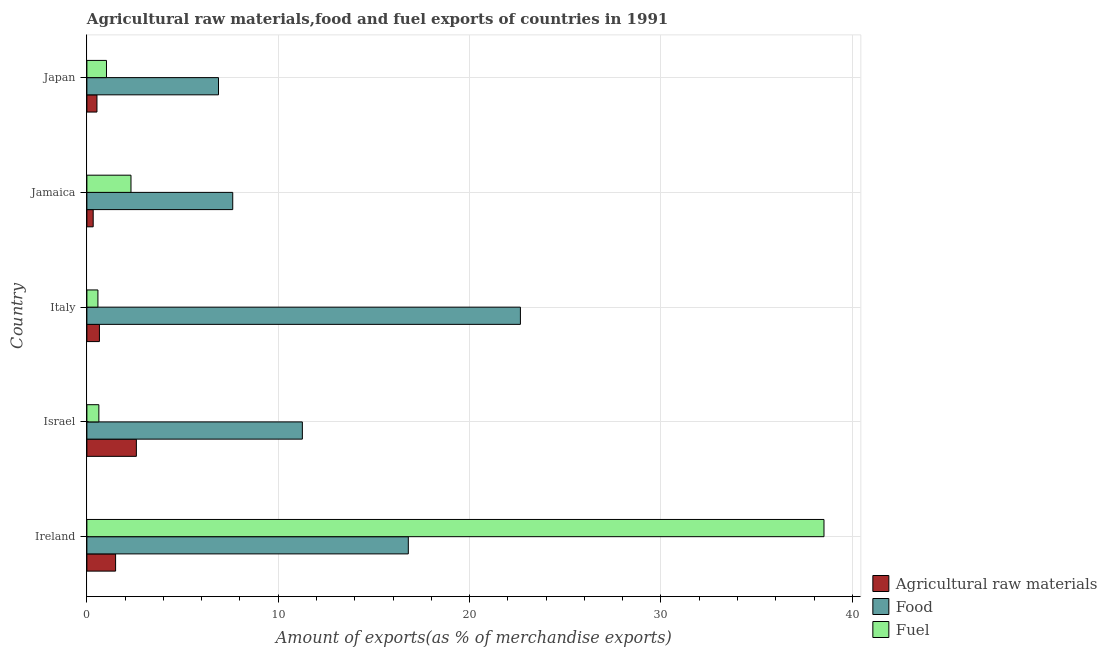Are the number of bars per tick equal to the number of legend labels?
Provide a short and direct response. Yes. How many bars are there on the 2nd tick from the bottom?
Provide a short and direct response. 3. What is the percentage of raw materials exports in Israel?
Give a very brief answer. 2.59. Across all countries, what is the maximum percentage of food exports?
Your response must be concise. 22.66. Across all countries, what is the minimum percentage of raw materials exports?
Keep it short and to the point. 0.33. In which country was the percentage of food exports minimum?
Offer a very short reply. Japan. What is the total percentage of raw materials exports in the graph?
Provide a succinct answer. 5.6. What is the difference between the percentage of raw materials exports in Japan and the percentage of food exports in Italy?
Keep it short and to the point. -22.13. What is the average percentage of food exports per country?
Give a very brief answer. 13.04. What is the difference between the percentage of raw materials exports and percentage of fuel exports in Japan?
Give a very brief answer. -0.5. What is the ratio of the percentage of food exports in Ireland to that in Italy?
Ensure brevity in your answer.  0.74. Is the percentage of fuel exports in Israel less than that in Italy?
Make the answer very short. No. What is the difference between the highest and the second highest percentage of food exports?
Give a very brief answer. 5.86. What is the difference between the highest and the lowest percentage of fuel exports?
Ensure brevity in your answer.  37.94. Is the sum of the percentage of fuel exports in Israel and Italy greater than the maximum percentage of raw materials exports across all countries?
Your answer should be compact. No. What does the 3rd bar from the top in Italy represents?
Keep it short and to the point. Agricultural raw materials. What does the 2nd bar from the bottom in Jamaica represents?
Provide a short and direct response. Food. Is it the case that in every country, the sum of the percentage of raw materials exports and percentage of food exports is greater than the percentage of fuel exports?
Give a very brief answer. No. How many countries are there in the graph?
Your answer should be very brief. 5. What is the title of the graph?
Provide a short and direct response. Agricultural raw materials,food and fuel exports of countries in 1991. What is the label or title of the X-axis?
Your response must be concise. Amount of exports(as % of merchandise exports). What is the label or title of the Y-axis?
Your answer should be very brief. Country. What is the Amount of exports(as % of merchandise exports) of Agricultural raw materials in Ireland?
Your answer should be compact. 1.5. What is the Amount of exports(as % of merchandise exports) in Food in Ireland?
Ensure brevity in your answer.  16.8. What is the Amount of exports(as % of merchandise exports) of Fuel in Ireland?
Provide a short and direct response. 38.52. What is the Amount of exports(as % of merchandise exports) of Agricultural raw materials in Israel?
Ensure brevity in your answer.  2.59. What is the Amount of exports(as % of merchandise exports) of Food in Israel?
Your answer should be compact. 11.26. What is the Amount of exports(as % of merchandise exports) of Fuel in Israel?
Ensure brevity in your answer.  0.62. What is the Amount of exports(as % of merchandise exports) of Agricultural raw materials in Italy?
Give a very brief answer. 0.66. What is the Amount of exports(as % of merchandise exports) in Food in Italy?
Ensure brevity in your answer.  22.66. What is the Amount of exports(as % of merchandise exports) in Fuel in Italy?
Keep it short and to the point. 0.58. What is the Amount of exports(as % of merchandise exports) of Agricultural raw materials in Jamaica?
Your answer should be compact. 0.33. What is the Amount of exports(as % of merchandise exports) of Food in Jamaica?
Your answer should be very brief. 7.62. What is the Amount of exports(as % of merchandise exports) of Fuel in Jamaica?
Make the answer very short. 2.3. What is the Amount of exports(as % of merchandise exports) of Agricultural raw materials in Japan?
Your answer should be compact. 0.53. What is the Amount of exports(as % of merchandise exports) in Food in Japan?
Your answer should be compact. 6.88. What is the Amount of exports(as % of merchandise exports) in Fuel in Japan?
Offer a terse response. 1.02. Across all countries, what is the maximum Amount of exports(as % of merchandise exports) of Agricultural raw materials?
Your answer should be compact. 2.59. Across all countries, what is the maximum Amount of exports(as % of merchandise exports) of Food?
Give a very brief answer. 22.66. Across all countries, what is the maximum Amount of exports(as % of merchandise exports) in Fuel?
Your answer should be very brief. 38.52. Across all countries, what is the minimum Amount of exports(as % of merchandise exports) in Agricultural raw materials?
Ensure brevity in your answer.  0.33. Across all countries, what is the minimum Amount of exports(as % of merchandise exports) in Food?
Make the answer very short. 6.88. Across all countries, what is the minimum Amount of exports(as % of merchandise exports) of Fuel?
Your answer should be compact. 0.58. What is the total Amount of exports(as % of merchandise exports) in Agricultural raw materials in the graph?
Make the answer very short. 5.6. What is the total Amount of exports(as % of merchandise exports) of Food in the graph?
Keep it short and to the point. 65.21. What is the total Amount of exports(as % of merchandise exports) in Fuel in the graph?
Provide a short and direct response. 43.05. What is the difference between the Amount of exports(as % of merchandise exports) in Agricultural raw materials in Ireland and that in Israel?
Offer a very short reply. -1.09. What is the difference between the Amount of exports(as % of merchandise exports) in Food in Ireland and that in Israel?
Provide a succinct answer. 5.54. What is the difference between the Amount of exports(as % of merchandise exports) of Fuel in Ireland and that in Israel?
Your answer should be very brief. 37.89. What is the difference between the Amount of exports(as % of merchandise exports) of Agricultural raw materials in Ireland and that in Italy?
Provide a succinct answer. 0.84. What is the difference between the Amount of exports(as % of merchandise exports) in Food in Ireland and that in Italy?
Make the answer very short. -5.86. What is the difference between the Amount of exports(as % of merchandise exports) of Fuel in Ireland and that in Italy?
Offer a very short reply. 37.94. What is the difference between the Amount of exports(as % of merchandise exports) of Agricultural raw materials in Ireland and that in Jamaica?
Provide a succinct answer. 1.17. What is the difference between the Amount of exports(as % of merchandise exports) of Food in Ireland and that in Jamaica?
Ensure brevity in your answer.  9.18. What is the difference between the Amount of exports(as % of merchandise exports) in Fuel in Ireland and that in Jamaica?
Your answer should be very brief. 36.22. What is the difference between the Amount of exports(as % of merchandise exports) in Food in Ireland and that in Japan?
Your answer should be very brief. 9.92. What is the difference between the Amount of exports(as % of merchandise exports) of Fuel in Ireland and that in Japan?
Provide a succinct answer. 37.5. What is the difference between the Amount of exports(as % of merchandise exports) in Agricultural raw materials in Israel and that in Italy?
Keep it short and to the point. 1.93. What is the difference between the Amount of exports(as % of merchandise exports) in Food in Israel and that in Italy?
Provide a short and direct response. -11.39. What is the difference between the Amount of exports(as % of merchandise exports) in Fuel in Israel and that in Italy?
Ensure brevity in your answer.  0.05. What is the difference between the Amount of exports(as % of merchandise exports) in Agricultural raw materials in Israel and that in Jamaica?
Provide a succinct answer. 2.26. What is the difference between the Amount of exports(as % of merchandise exports) in Food in Israel and that in Jamaica?
Offer a terse response. 3.64. What is the difference between the Amount of exports(as % of merchandise exports) of Fuel in Israel and that in Jamaica?
Provide a short and direct response. -1.68. What is the difference between the Amount of exports(as % of merchandise exports) in Agricultural raw materials in Israel and that in Japan?
Provide a short and direct response. 2.06. What is the difference between the Amount of exports(as % of merchandise exports) of Food in Israel and that in Japan?
Offer a terse response. 4.38. What is the difference between the Amount of exports(as % of merchandise exports) in Fuel in Israel and that in Japan?
Your answer should be compact. -0.4. What is the difference between the Amount of exports(as % of merchandise exports) of Agricultural raw materials in Italy and that in Jamaica?
Provide a succinct answer. 0.33. What is the difference between the Amount of exports(as % of merchandise exports) of Food in Italy and that in Jamaica?
Provide a short and direct response. 15.03. What is the difference between the Amount of exports(as % of merchandise exports) of Fuel in Italy and that in Jamaica?
Give a very brief answer. -1.73. What is the difference between the Amount of exports(as % of merchandise exports) in Agricultural raw materials in Italy and that in Japan?
Provide a short and direct response. 0.13. What is the difference between the Amount of exports(as % of merchandise exports) in Food in Italy and that in Japan?
Make the answer very short. 15.78. What is the difference between the Amount of exports(as % of merchandise exports) in Fuel in Italy and that in Japan?
Make the answer very short. -0.45. What is the difference between the Amount of exports(as % of merchandise exports) in Agricultural raw materials in Jamaica and that in Japan?
Offer a very short reply. -0.2. What is the difference between the Amount of exports(as % of merchandise exports) of Food in Jamaica and that in Japan?
Your answer should be very brief. 0.74. What is the difference between the Amount of exports(as % of merchandise exports) in Fuel in Jamaica and that in Japan?
Ensure brevity in your answer.  1.28. What is the difference between the Amount of exports(as % of merchandise exports) in Agricultural raw materials in Ireland and the Amount of exports(as % of merchandise exports) in Food in Israel?
Keep it short and to the point. -9.76. What is the difference between the Amount of exports(as % of merchandise exports) of Agricultural raw materials in Ireland and the Amount of exports(as % of merchandise exports) of Fuel in Israel?
Offer a terse response. 0.87. What is the difference between the Amount of exports(as % of merchandise exports) in Food in Ireland and the Amount of exports(as % of merchandise exports) in Fuel in Israel?
Make the answer very short. 16.17. What is the difference between the Amount of exports(as % of merchandise exports) of Agricultural raw materials in Ireland and the Amount of exports(as % of merchandise exports) of Food in Italy?
Provide a short and direct response. -21.16. What is the difference between the Amount of exports(as % of merchandise exports) in Agricultural raw materials in Ireland and the Amount of exports(as % of merchandise exports) in Fuel in Italy?
Your answer should be compact. 0.92. What is the difference between the Amount of exports(as % of merchandise exports) of Food in Ireland and the Amount of exports(as % of merchandise exports) of Fuel in Italy?
Provide a short and direct response. 16.22. What is the difference between the Amount of exports(as % of merchandise exports) of Agricultural raw materials in Ireland and the Amount of exports(as % of merchandise exports) of Food in Jamaica?
Give a very brief answer. -6.12. What is the difference between the Amount of exports(as % of merchandise exports) of Agricultural raw materials in Ireland and the Amount of exports(as % of merchandise exports) of Fuel in Jamaica?
Make the answer very short. -0.8. What is the difference between the Amount of exports(as % of merchandise exports) of Food in Ireland and the Amount of exports(as % of merchandise exports) of Fuel in Jamaica?
Your answer should be compact. 14.49. What is the difference between the Amount of exports(as % of merchandise exports) of Agricultural raw materials in Ireland and the Amount of exports(as % of merchandise exports) of Food in Japan?
Make the answer very short. -5.38. What is the difference between the Amount of exports(as % of merchandise exports) of Agricultural raw materials in Ireland and the Amount of exports(as % of merchandise exports) of Fuel in Japan?
Your answer should be very brief. 0.48. What is the difference between the Amount of exports(as % of merchandise exports) of Food in Ireland and the Amount of exports(as % of merchandise exports) of Fuel in Japan?
Offer a very short reply. 15.77. What is the difference between the Amount of exports(as % of merchandise exports) in Agricultural raw materials in Israel and the Amount of exports(as % of merchandise exports) in Food in Italy?
Provide a short and direct response. -20.07. What is the difference between the Amount of exports(as % of merchandise exports) of Agricultural raw materials in Israel and the Amount of exports(as % of merchandise exports) of Fuel in Italy?
Ensure brevity in your answer.  2.01. What is the difference between the Amount of exports(as % of merchandise exports) of Food in Israel and the Amount of exports(as % of merchandise exports) of Fuel in Italy?
Give a very brief answer. 10.68. What is the difference between the Amount of exports(as % of merchandise exports) in Agricultural raw materials in Israel and the Amount of exports(as % of merchandise exports) in Food in Jamaica?
Make the answer very short. -5.04. What is the difference between the Amount of exports(as % of merchandise exports) of Agricultural raw materials in Israel and the Amount of exports(as % of merchandise exports) of Fuel in Jamaica?
Ensure brevity in your answer.  0.28. What is the difference between the Amount of exports(as % of merchandise exports) in Food in Israel and the Amount of exports(as % of merchandise exports) in Fuel in Jamaica?
Your answer should be compact. 8.96. What is the difference between the Amount of exports(as % of merchandise exports) of Agricultural raw materials in Israel and the Amount of exports(as % of merchandise exports) of Food in Japan?
Make the answer very short. -4.29. What is the difference between the Amount of exports(as % of merchandise exports) in Agricultural raw materials in Israel and the Amount of exports(as % of merchandise exports) in Fuel in Japan?
Make the answer very short. 1.56. What is the difference between the Amount of exports(as % of merchandise exports) in Food in Israel and the Amount of exports(as % of merchandise exports) in Fuel in Japan?
Keep it short and to the point. 10.24. What is the difference between the Amount of exports(as % of merchandise exports) of Agricultural raw materials in Italy and the Amount of exports(as % of merchandise exports) of Food in Jamaica?
Your answer should be very brief. -6.97. What is the difference between the Amount of exports(as % of merchandise exports) in Agricultural raw materials in Italy and the Amount of exports(as % of merchandise exports) in Fuel in Jamaica?
Your answer should be compact. -1.65. What is the difference between the Amount of exports(as % of merchandise exports) of Food in Italy and the Amount of exports(as % of merchandise exports) of Fuel in Jamaica?
Provide a short and direct response. 20.35. What is the difference between the Amount of exports(as % of merchandise exports) in Agricultural raw materials in Italy and the Amount of exports(as % of merchandise exports) in Food in Japan?
Your answer should be very brief. -6.22. What is the difference between the Amount of exports(as % of merchandise exports) in Agricultural raw materials in Italy and the Amount of exports(as % of merchandise exports) in Fuel in Japan?
Ensure brevity in your answer.  -0.37. What is the difference between the Amount of exports(as % of merchandise exports) of Food in Italy and the Amount of exports(as % of merchandise exports) of Fuel in Japan?
Give a very brief answer. 21.63. What is the difference between the Amount of exports(as % of merchandise exports) in Agricultural raw materials in Jamaica and the Amount of exports(as % of merchandise exports) in Food in Japan?
Keep it short and to the point. -6.55. What is the difference between the Amount of exports(as % of merchandise exports) in Agricultural raw materials in Jamaica and the Amount of exports(as % of merchandise exports) in Fuel in Japan?
Make the answer very short. -0.69. What is the difference between the Amount of exports(as % of merchandise exports) in Food in Jamaica and the Amount of exports(as % of merchandise exports) in Fuel in Japan?
Your response must be concise. 6.6. What is the average Amount of exports(as % of merchandise exports) of Agricultural raw materials per country?
Your answer should be compact. 1.12. What is the average Amount of exports(as % of merchandise exports) in Food per country?
Keep it short and to the point. 13.04. What is the average Amount of exports(as % of merchandise exports) in Fuel per country?
Make the answer very short. 8.61. What is the difference between the Amount of exports(as % of merchandise exports) of Agricultural raw materials and Amount of exports(as % of merchandise exports) of Food in Ireland?
Provide a succinct answer. -15.3. What is the difference between the Amount of exports(as % of merchandise exports) in Agricultural raw materials and Amount of exports(as % of merchandise exports) in Fuel in Ireland?
Ensure brevity in your answer.  -37.02. What is the difference between the Amount of exports(as % of merchandise exports) in Food and Amount of exports(as % of merchandise exports) in Fuel in Ireland?
Offer a terse response. -21.72. What is the difference between the Amount of exports(as % of merchandise exports) in Agricultural raw materials and Amount of exports(as % of merchandise exports) in Food in Israel?
Provide a short and direct response. -8.67. What is the difference between the Amount of exports(as % of merchandise exports) in Agricultural raw materials and Amount of exports(as % of merchandise exports) in Fuel in Israel?
Your answer should be very brief. 1.96. What is the difference between the Amount of exports(as % of merchandise exports) in Food and Amount of exports(as % of merchandise exports) in Fuel in Israel?
Your answer should be very brief. 10.64. What is the difference between the Amount of exports(as % of merchandise exports) in Agricultural raw materials and Amount of exports(as % of merchandise exports) in Fuel in Italy?
Ensure brevity in your answer.  0.08. What is the difference between the Amount of exports(as % of merchandise exports) of Food and Amount of exports(as % of merchandise exports) of Fuel in Italy?
Offer a terse response. 22.08. What is the difference between the Amount of exports(as % of merchandise exports) in Agricultural raw materials and Amount of exports(as % of merchandise exports) in Food in Jamaica?
Your answer should be very brief. -7.29. What is the difference between the Amount of exports(as % of merchandise exports) in Agricultural raw materials and Amount of exports(as % of merchandise exports) in Fuel in Jamaica?
Keep it short and to the point. -1.98. What is the difference between the Amount of exports(as % of merchandise exports) of Food and Amount of exports(as % of merchandise exports) of Fuel in Jamaica?
Your response must be concise. 5.32. What is the difference between the Amount of exports(as % of merchandise exports) in Agricultural raw materials and Amount of exports(as % of merchandise exports) in Food in Japan?
Your response must be concise. -6.35. What is the difference between the Amount of exports(as % of merchandise exports) of Agricultural raw materials and Amount of exports(as % of merchandise exports) of Fuel in Japan?
Provide a short and direct response. -0.5. What is the difference between the Amount of exports(as % of merchandise exports) in Food and Amount of exports(as % of merchandise exports) in Fuel in Japan?
Give a very brief answer. 5.85. What is the ratio of the Amount of exports(as % of merchandise exports) in Agricultural raw materials in Ireland to that in Israel?
Make the answer very short. 0.58. What is the ratio of the Amount of exports(as % of merchandise exports) of Food in Ireland to that in Israel?
Offer a terse response. 1.49. What is the ratio of the Amount of exports(as % of merchandise exports) of Fuel in Ireland to that in Israel?
Your answer should be compact. 61.63. What is the ratio of the Amount of exports(as % of merchandise exports) in Agricultural raw materials in Ireland to that in Italy?
Provide a short and direct response. 2.29. What is the ratio of the Amount of exports(as % of merchandise exports) in Food in Ireland to that in Italy?
Provide a short and direct response. 0.74. What is the ratio of the Amount of exports(as % of merchandise exports) in Fuel in Ireland to that in Italy?
Offer a terse response. 66.87. What is the ratio of the Amount of exports(as % of merchandise exports) of Agricultural raw materials in Ireland to that in Jamaica?
Your answer should be compact. 4.56. What is the ratio of the Amount of exports(as % of merchandise exports) of Food in Ireland to that in Jamaica?
Provide a short and direct response. 2.2. What is the ratio of the Amount of exports(as % of merchandise exports) in Fuel in Ireland to that in Jamaica?
Give a very brief answer. 16.72. What is the ratio of the Amount of exports(as % of merchandise exports) in Agricultural raw materials in Ireland to that in Japan?
Make the answer very short. 2.85. What is the ratio of the Amount of exports(as % of merchandise exports) of Food in Ireland to that in Japan?
Provide a short and direct response. 2.44. What is the ratio of the Amount of exports(as % of merchandise exports) of Fuel in Ireland to that in Japan?
Provide a short and direct response. 37.63. What is the ratio of the Amount of exports(as % of merchandise exports) in Agricultural raw materials in Israel to that in Italy?
Ensure brevity in your answer.  3.95. What is the ratio of the Amount of exports(as % of merchandise exports) in Food in Israel to that in Italy?
Offer a terse response. 0.5. What is the ratio of the Amount of exports(as % of merchandise exports) of Fuel in Israel to that in Italy?
Your response must be concise. 1.08. What is the ratio of the Amount of exports(as % of merchandise exports) in Agricultural raw materials in Israel to that in Jamaica?
Give a very brief answer. 7.86. What is the ratio of the Amount of exports(as % of merchandise exports) of Food in Israel to that in Jamaica?
Your answer should be compact. 1.48. What is the ratio of the Amount of exports(as % of merchandise exports) of Fuel in Israel to that in Jamaica?
Give a very brief answer. 0.27. What is the ratio of the Amount of exports(as % of merchandise exports) of Agricultural raw materials in Israel to that in Japan?
Your response must be concise. 4.92. What is the ratio of the Amount of exports(as % of merchandise exports) of Food in Israel to that in Japan?
Ensure brevity in your answer.  1.64. What is the ratio of the Amount of exports(as % of merchandise exports) in Fuel in Israel to that in Japan?
Your answer should be very brief. 0.61. What is the ratio of the Amount of exports(as % of merchandise exports) of Agricultural raw materials in Italy to that in Jamaica?
Provide a short and direct response. 1.99. What is the ratio of the Amount of exports(as % of merchandise exports) of Food in Italy to that in Jamaica?
Ensure brevity in your answer.  2.97. What is the ratio of the Amount of exports(as % of merchandise exports) of Fuel in Italy to that in Jamaica?
Offer a terse response. 0.25. What is the ratio of the Amount of exports(as % of merchandise exports) in Agricultural raw materials in Italy to that in Japan?
Offer a very short reply. 1.25. What is the ratio of the Amount of exports(as % of merchandise exports) of Food in Italy to that in Japan?
Keep it short and to the point. 3.29. What is the ratio of the Amount of exports(as % of merchandise exports) of Fuel in Italy to that in Japan?
Your answer should be compact. 0.56. What is the ratio of the Amount of exports(as % of merchandise exports) in Agricultural raw materials in Jamaica to that in Japan?
Give a very brief answer. 0.63. What is the ratio of the Amount of exports(as % of merchandise exports) of Food in Jamaica to that in Japan?
Make the answer very short. 1.11. What is the ratio of the Amount of exports(as % of merchandise exports) in Fuel in Jamaica to that in Japan?
Provide a short and direct response. 2.25. What is the difference between the highest and the second highest Amount of exports(as % of merchandise exports) in Agricultural raw materials?
Ensure brevity in your answer.  1.09. What is the difference between the highest and the second highest Amount of exports(as % of merchandise exports) in Food?
Ensure brevity in your answer.  5.86. What is the difference between the highest and the second highest Amount of exports(as % of merchandise exports) in Fuel?
Provide a succinct answer. 36.22. What is the difference between the highest and the lowest Amount of exports(as % of merchandise exports) of Agricultural raw materials?
Offer a terse response. 2.26. What is the difference between the highest and the lowest Amount of exports(as % of merchandise exports) in Food?
Ensure brevity in your answer.  15.78. What is the difference between the highest and the lowest Amount of exports(as % of merchandise exports) in Fuel?
Give a very brief answer. 37.94. 